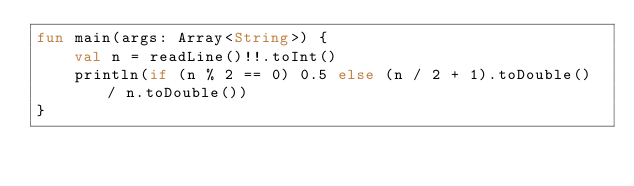Convert code to text. <code><loc_0><loc_0><loc_500><loc_500><_Kotlin_>fun main(args: Array<String>) {
    val n = readLine()!!.toInt()
    println(if (n % 2 == 0) 0.5 else (n / 2 + 1).toDouble() / n.toDouble())
}</code> 